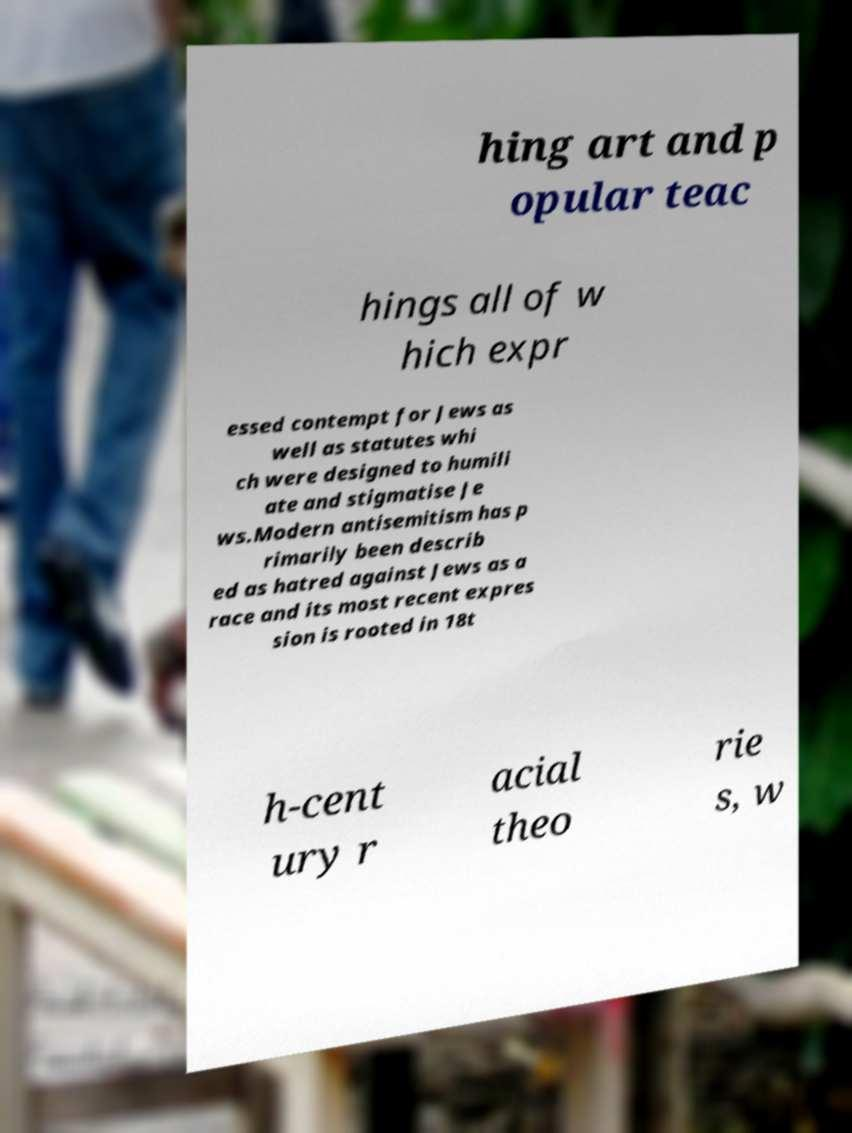Please read and relay the text visible in this image. What does it say? hing art and p opular teac hings all of w hich expr essed contempt for Jews as well as statutes whi ch were designed to humili ate and stigmatise Je ws.Modern antisemitism has p rimarily been describ ed as hatred against Jews as a race and its most recent expres sion is rooted in 18t h-cent ury r acial theo rie s, w 